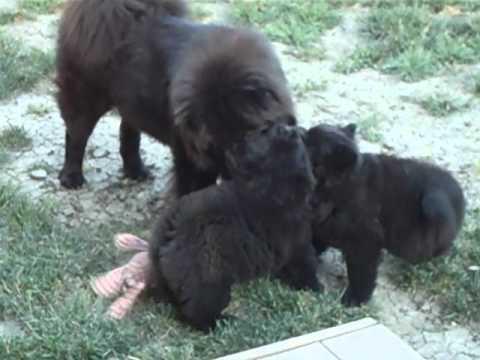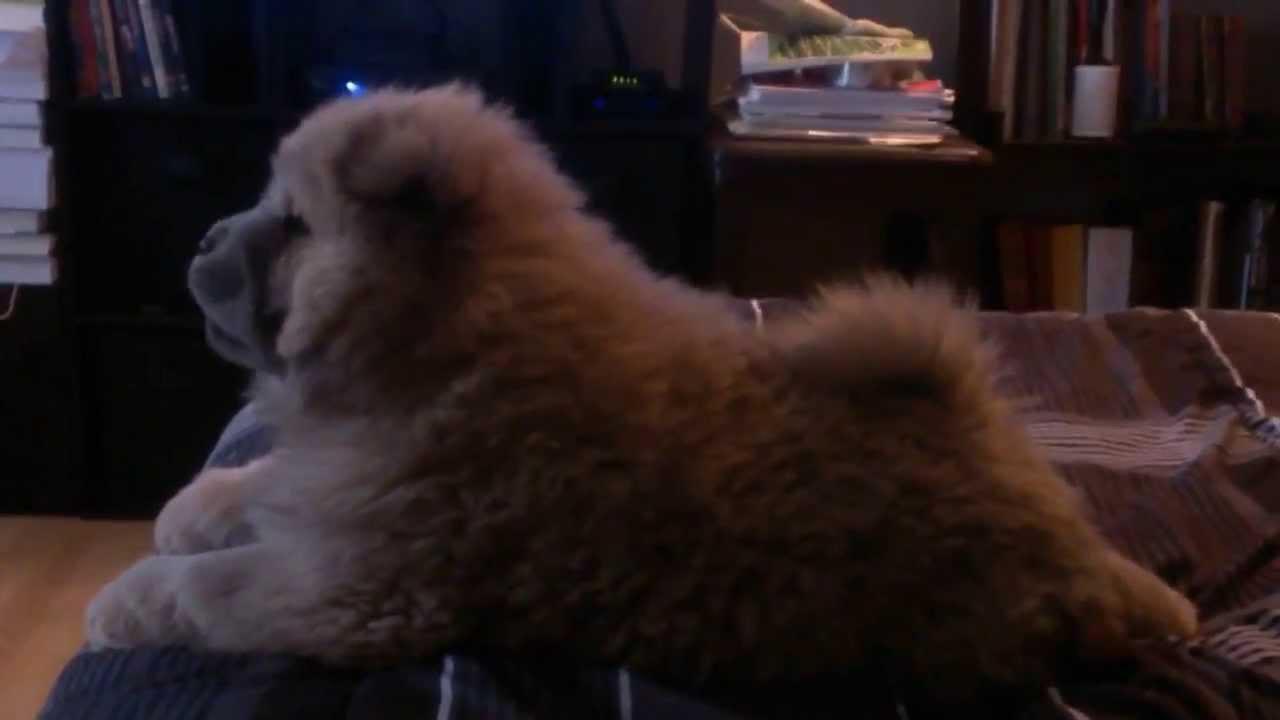The first image is the image on the left, the second image is the image on the right. Given the left and right images, does the statement "One image in the pair shows a single black dog and the other shows a single tan dog." hold true? Answer yes or no. No. The first image is the image on the left, the second image is the image on the right. Assess this claim about the two images: "A person holds up a chow puppy in the left image, and the right image features a black chow puppy in front of a metal fence-like barrier.". Correct or not? Answer yes or no. No. 